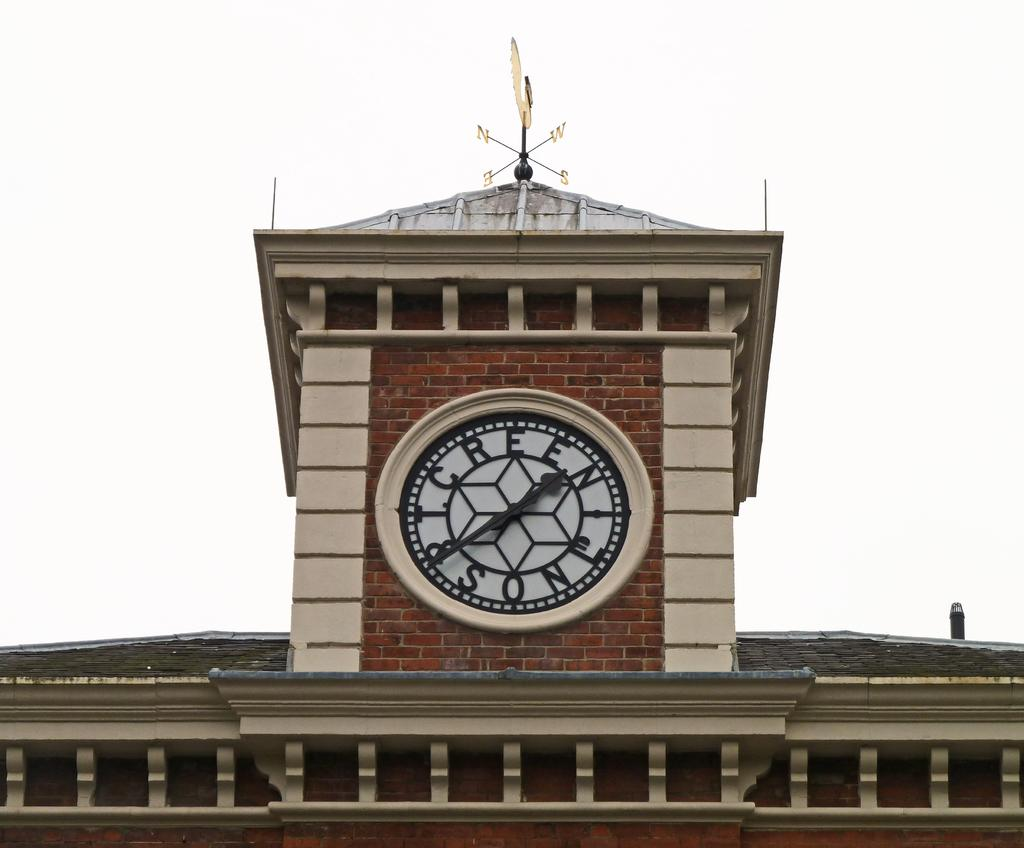<image>
Summarize the visual content of the image. A large clock on top of a building and has the word son on the edge of the face. 